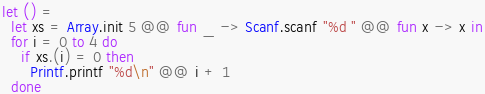<code> <loc_0><loc_0><loc_500><loc_500><_OCaml_>let () =
  let xs = Array.init 5 @@ fun _ -> Scanf.scanf "%d " @@ fun x -> x in
  for i = 0 to 4 do
    if xs.(i) = 0 then
      Printf.printf "%d\n" @@ i + 1
  done
</code> 